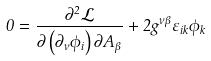<formula> <loc_0><loc_0><loc_500><loc_500>0 = \frac { \partial ^ { 2 } \mathcal { L } } { \partial \left ( \partial _ { \nu } \phi _ { i } \right ) \partial A _ { \beta } } + 2 g ^ { \nu \beta } \varepsilon _ { i k } \phi _ { k }</formula> 